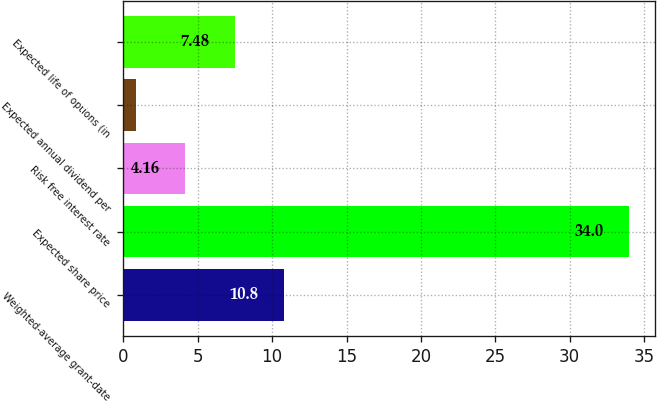Convert chart. <chart><loc_0><loc_0><loc_500><loc_500><bar_chart><fcel>Weighted-average grant-date<fcel>Expected share price<fcel>Risk free interest rate<fcel>Expected annual dividend per<fcel>Expected life of options (in<nl><fcel>10.8<fcel>34<fcel>4.16<fcel>0.84<fcel>7.48<nl></chart> 